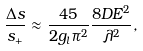<formula> <loc_0><loc_0><loc_500><loc_500>\frac { \Delta s } { s _ { + } } \approx \frac { 4 5 } { 2 g _ { l } \pi ^ { 2 } } \frac { 8 D E ^ { 2 } } { \lambda ^ { 2 } } ,</formula> 